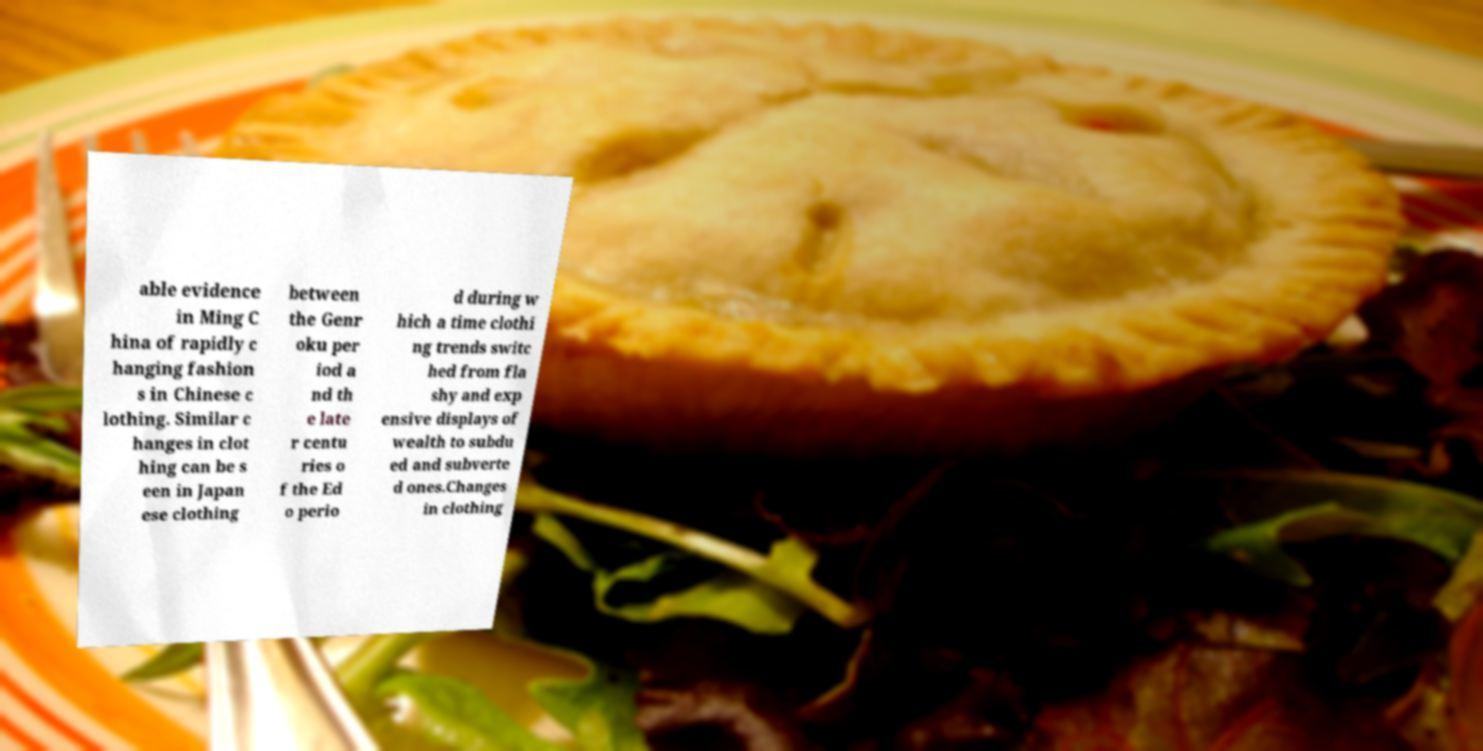For documentation purposes, I need the text within this image transcribed. Could you provide that? able evidence in Ming C hina of rapidly c hanging fashion s in Chinese c lothing. Similar c hanges in clot hing can be s een in Japan ese clothing between the Genr oku per iod a nd th e late r centu ries o f the Ed o perio d during w hich a time clothi ng trends switc hed from fla shy and exp ensive displays of wealth to subdu ed and subverte d ones.Changes in clothing 